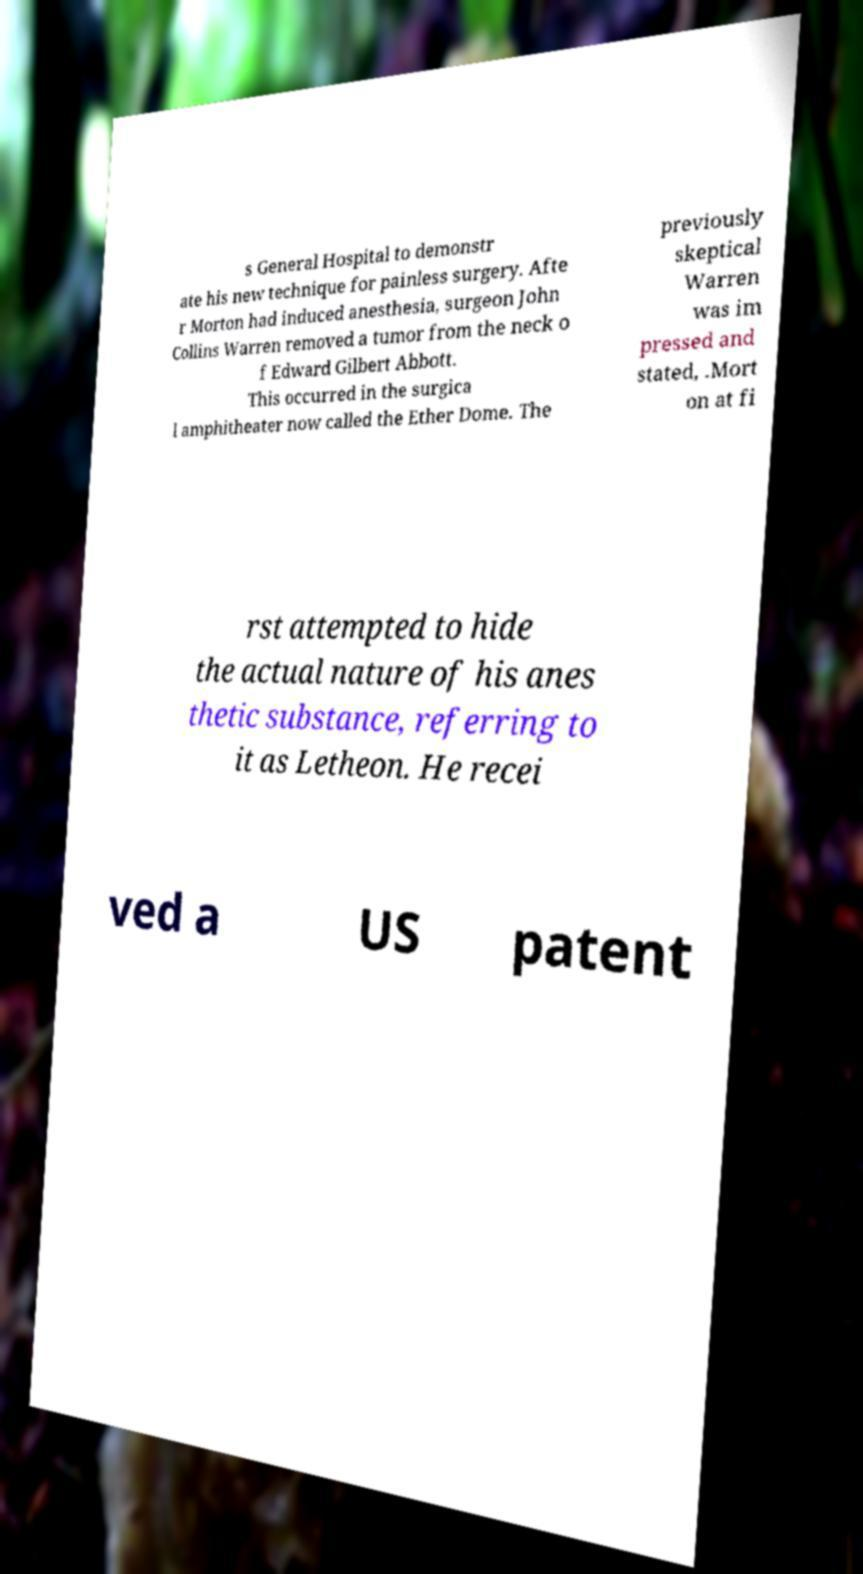What messages or text are displayed in this image? I need them in a readable, typed format. s General Hospital to demonstr ate his new technique for painless surgery. Afte r Morton had induced anesthesia, surgeon John Collins Warren removed a tumor from the neck o f Edward Gilbert Abbott. This occurred in the surgica l amphitheater now called the Ether Dome. The previously skeptical Warren was im pressed and stated, .Mort on at fi rst attempted to hide the actual nature of his anes thetic substance, referring to it as Letheon. He recei ved a US patent 